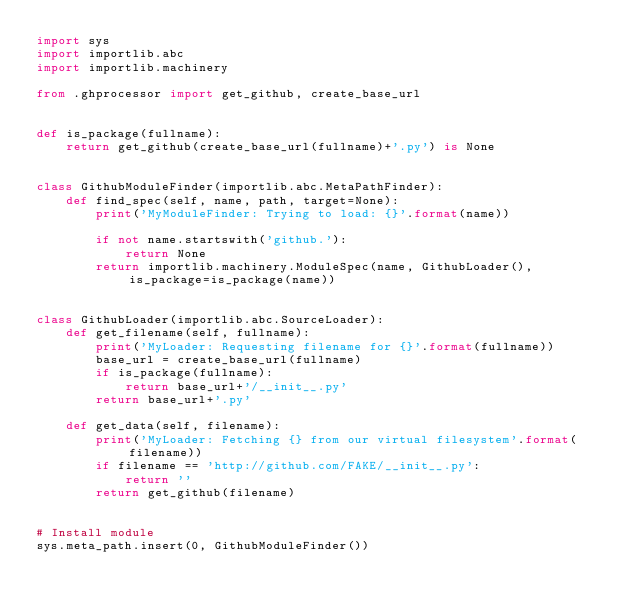<code> <loc_0><loc_0><loc_500><loc_500><_Python_>import sys
import importlib.abc
import importlib.machinery

from .ghprocessor import get_github, create_base_url


def is_package(fullname):
    return get_github(create_base_url(fullname)+'.py') is None


class GithubModuleFinder(importlib.abc.MetaPathFinder):
    def find_spec(self, name, path, target=None):
        print('MyModuleFinder: Trying to load: {}'.format(name))

        if not name.startswith('github.'):
            return None
        return importlib.machinery.ModuleSpec(name, GithubLoader(), is_package=is_package(name))


class GithubLoader(importlib.abc.SourceLoader):
    def get_filename(self, fullname):
        print('MyLoader: Requesting filename for {}'.format(fullname))
        base_url = create_base_url(fullname)
        if is_package(fullname):
            return base_url+'/__init__.py'
        return base_url+'.py'

    def get_data(self, filename):
        print('MyLoader: Fetching {} from our virtual filesystem'.format(filename))
        if filename == 'http://github.com/FAKE/__init__.py':
            return ''
        return get_github(filename)


# Install module
sys.meta_path.insert(0, GithubModuleFinder())
</code> 